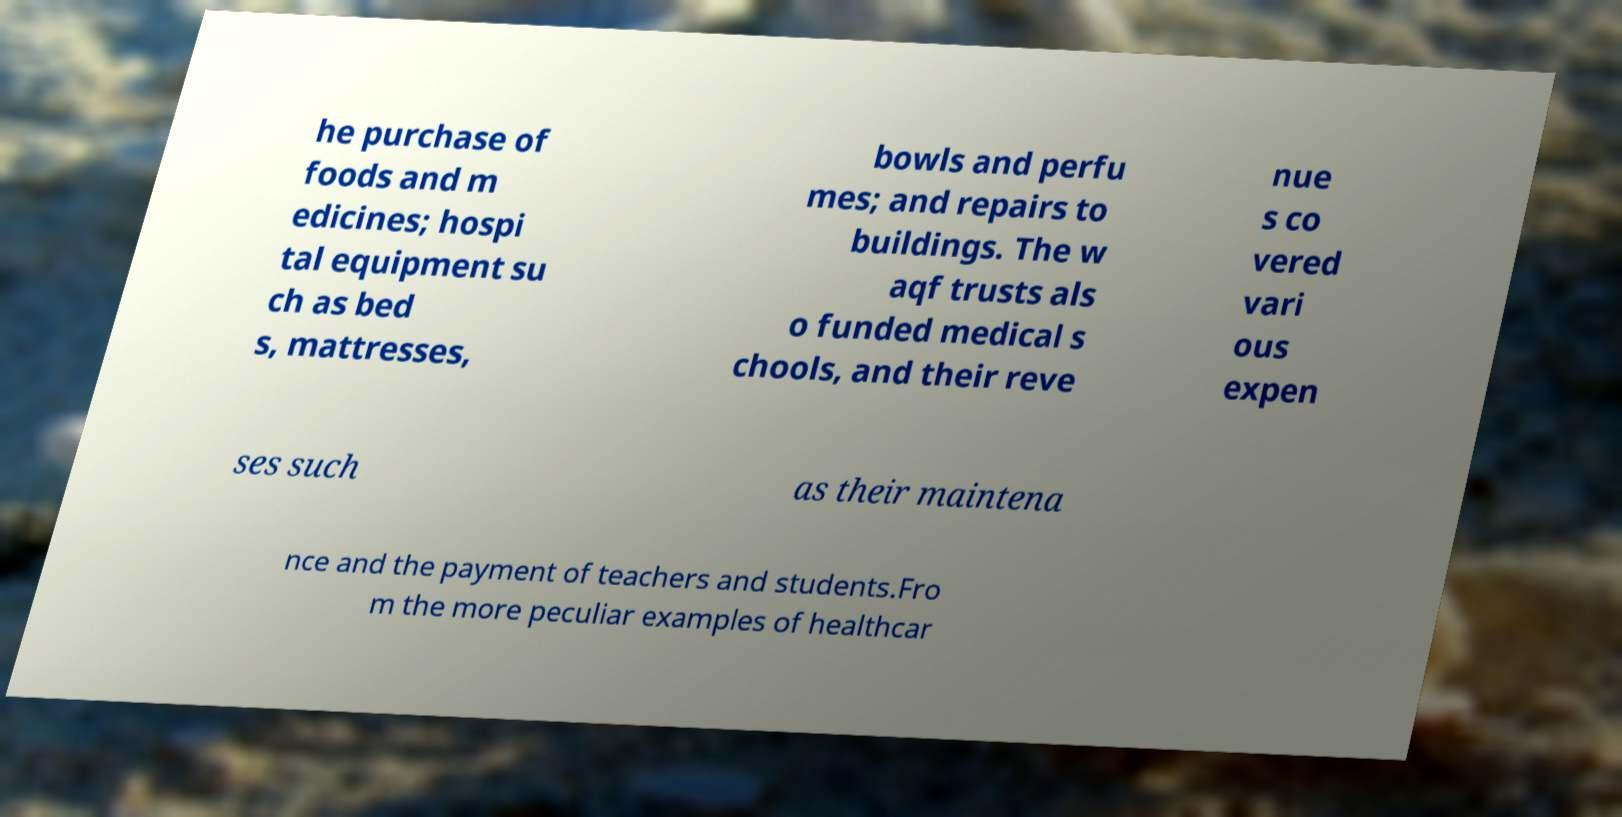There's text embedded in this image that I need extracted. Can you transcribe it verbatim? he purchase of foods and m edicines; hospi tal equipment su ch as bed s, mattresses, bowls and perfu mes; and repairs to buildings. The w aqf trusts als o funded medical s chools, and their reve nue s co vered vari ous expen ses such as their maintena nce and the payment of teachers and students.Fro m the more peculiar examples of healthcar 